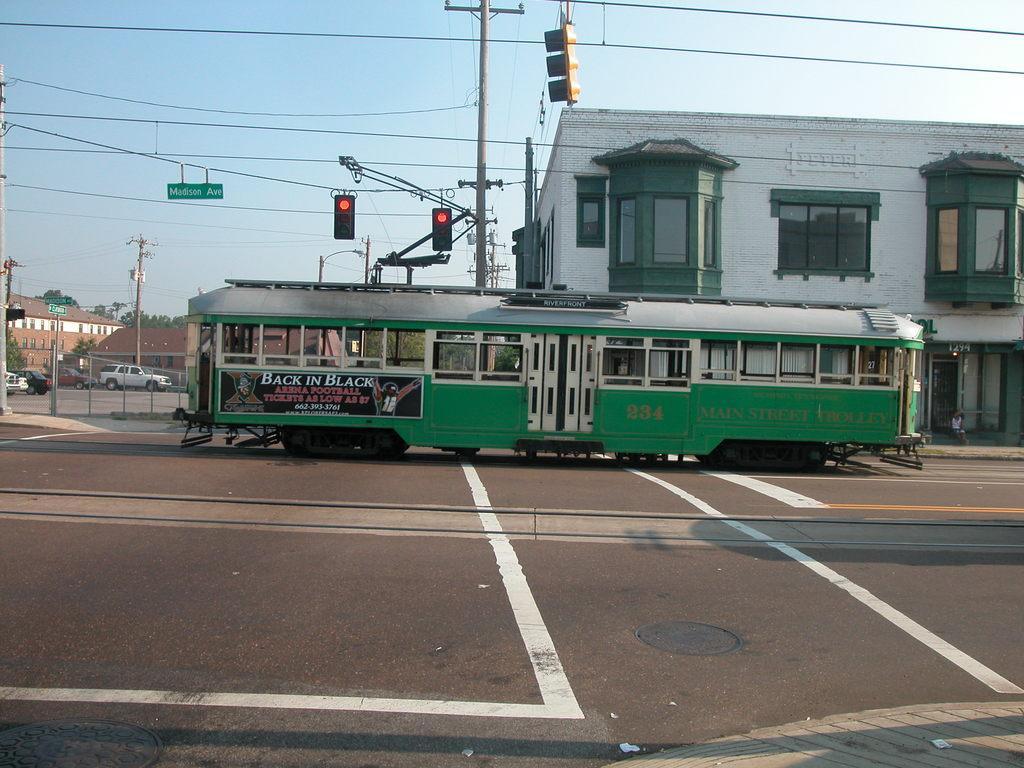How would you summarize this image in a sentence or two? In the middle of the image we can see a train on the tracks, in the background we can see few buildings, poles, traffic lights and cables, and also we can see few sign boards, fence and vehicles. 